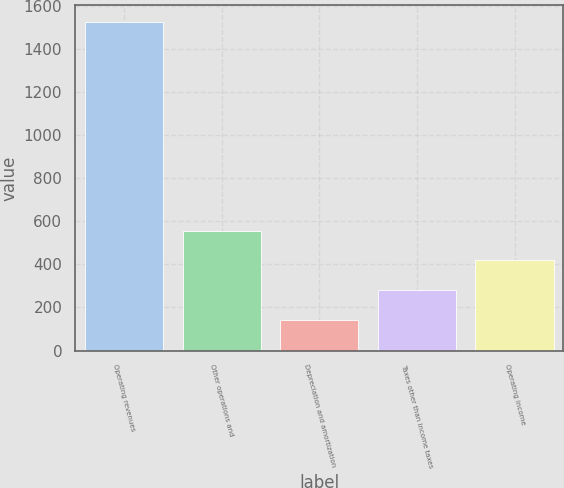Convert chart. <chart><loc_0><loc_0><loc_500><loc_500><bar_chart><fcel>Operating revenues<fcel>Other operations and<fcel>Depreciation and amortization<fcel>Taxes other than income taxes<fcel>Operating income<nl><fcel>1527<fcel>557.5<fcel>142<fcel>280.5<fcel>419<nl></chart> 